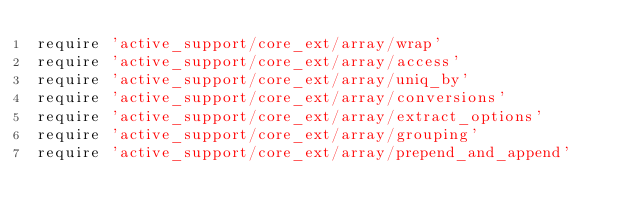Convert code to text. <code><loc_0><loc_0><loc_500><loc_500><_Ruby_>require 'active_support/core_ext/array/wrap'
require 'active_support/core_ext/array/access'
require 'active_support/core_ext/array/uniq_by'
require 'active_support/core_ext/array/conversions'
require 'active_support/core_ext/array/extract_options'
require 'active_support/core_ext/array/grouping'
require 'active_support/core_ext/array/prepend_and_append'
</code> 